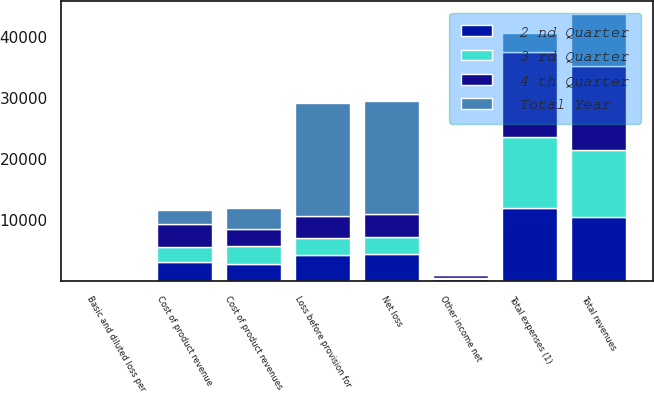Convert chart. <chart><loc_0><loc_0><loc_500><loc_500><stacked_bar_chart><ecel><fcel>Total revenues<fcel>Cost of product revenue<fcel>Total expenses (1)<fcel>Other income net<fcel>Loss before provision for<fcel>Net loss<fcel>Basic and diluted loss per<fcel>Cost of product revenues<nl><fcel>Total Year<fcel>8423<fcel>2333<fcel>3070<fcel>226<fcel>18508<fcel>18508<fcel>0.77<fcel>3483<nl><fcel>3 rd Quarter<fcel>10936<fcel>2448<fcel>11527<fcel>260<fcel>2779<fcel>2779<fcel>0.11<fcel>2925<nl><fcel>2 nd Quarter<fcel>10515<fcel>3070<fcel>11985<fcel>313<fcel>4227<fcel>4480<fcel>0.17<fcel>2873<nl><fcel>4 th Quarter<fcel>13796<fcel>3834<fcel>13940<fcel>399<fcel>3579<fcel>3682<fcel>0.14<fcel>2731<nl></chart> 